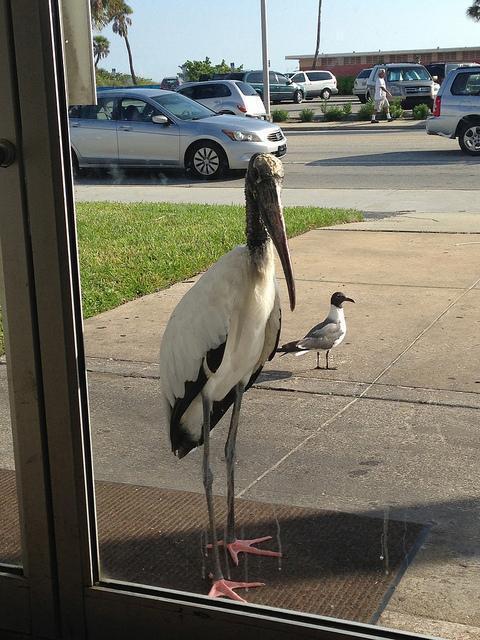How many birds are in the picture?
Give a very brief answer. 2. How many cars are there?
Give a very brief answer. 4. How many birds can you see?
Give a very brief answer. 2. How many ski poles are to the right of the skier?
Give a very brief answer. 0. 